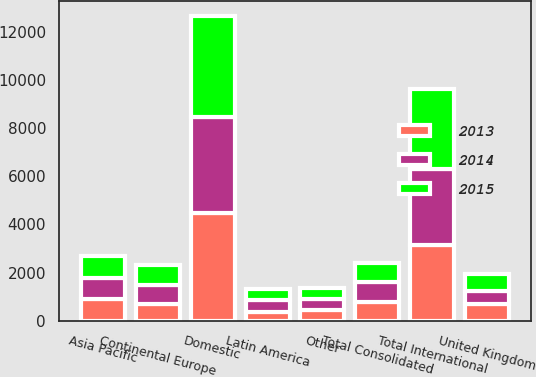<chart> <loc_0><loc_0><loc_500><loc_500><stacked_bar_chart><ecel><fcel>Domestic<fcel>United Kingdom<fcel>Continental Europe<fcel>Asia Pacific<fcel>Latin America<fcel>Other<fcel>Total International<fcel>Total Consolidated<nl><fcel>2013<fcel>4475.5<fcel>687.7<fcel>697.2<fcel>916.9<fcel>383.5<fcel>453<fcel>3138.3<fcel>800.6<nl><fcel>2015<fcel>4184<fcel>688.3<fcel>804.7<fcel>922.5<fcel>470.4<fcel>467.2<fcel>3353.1<fcel>800.6<nl><fcel>2014<fcel>3972.6<fcel>568.3<fcel>800.6<fcel>868.9<fcel>464.5<fcel>447.4<fcel>3149.7<fcel>800.6<nl></chart> 